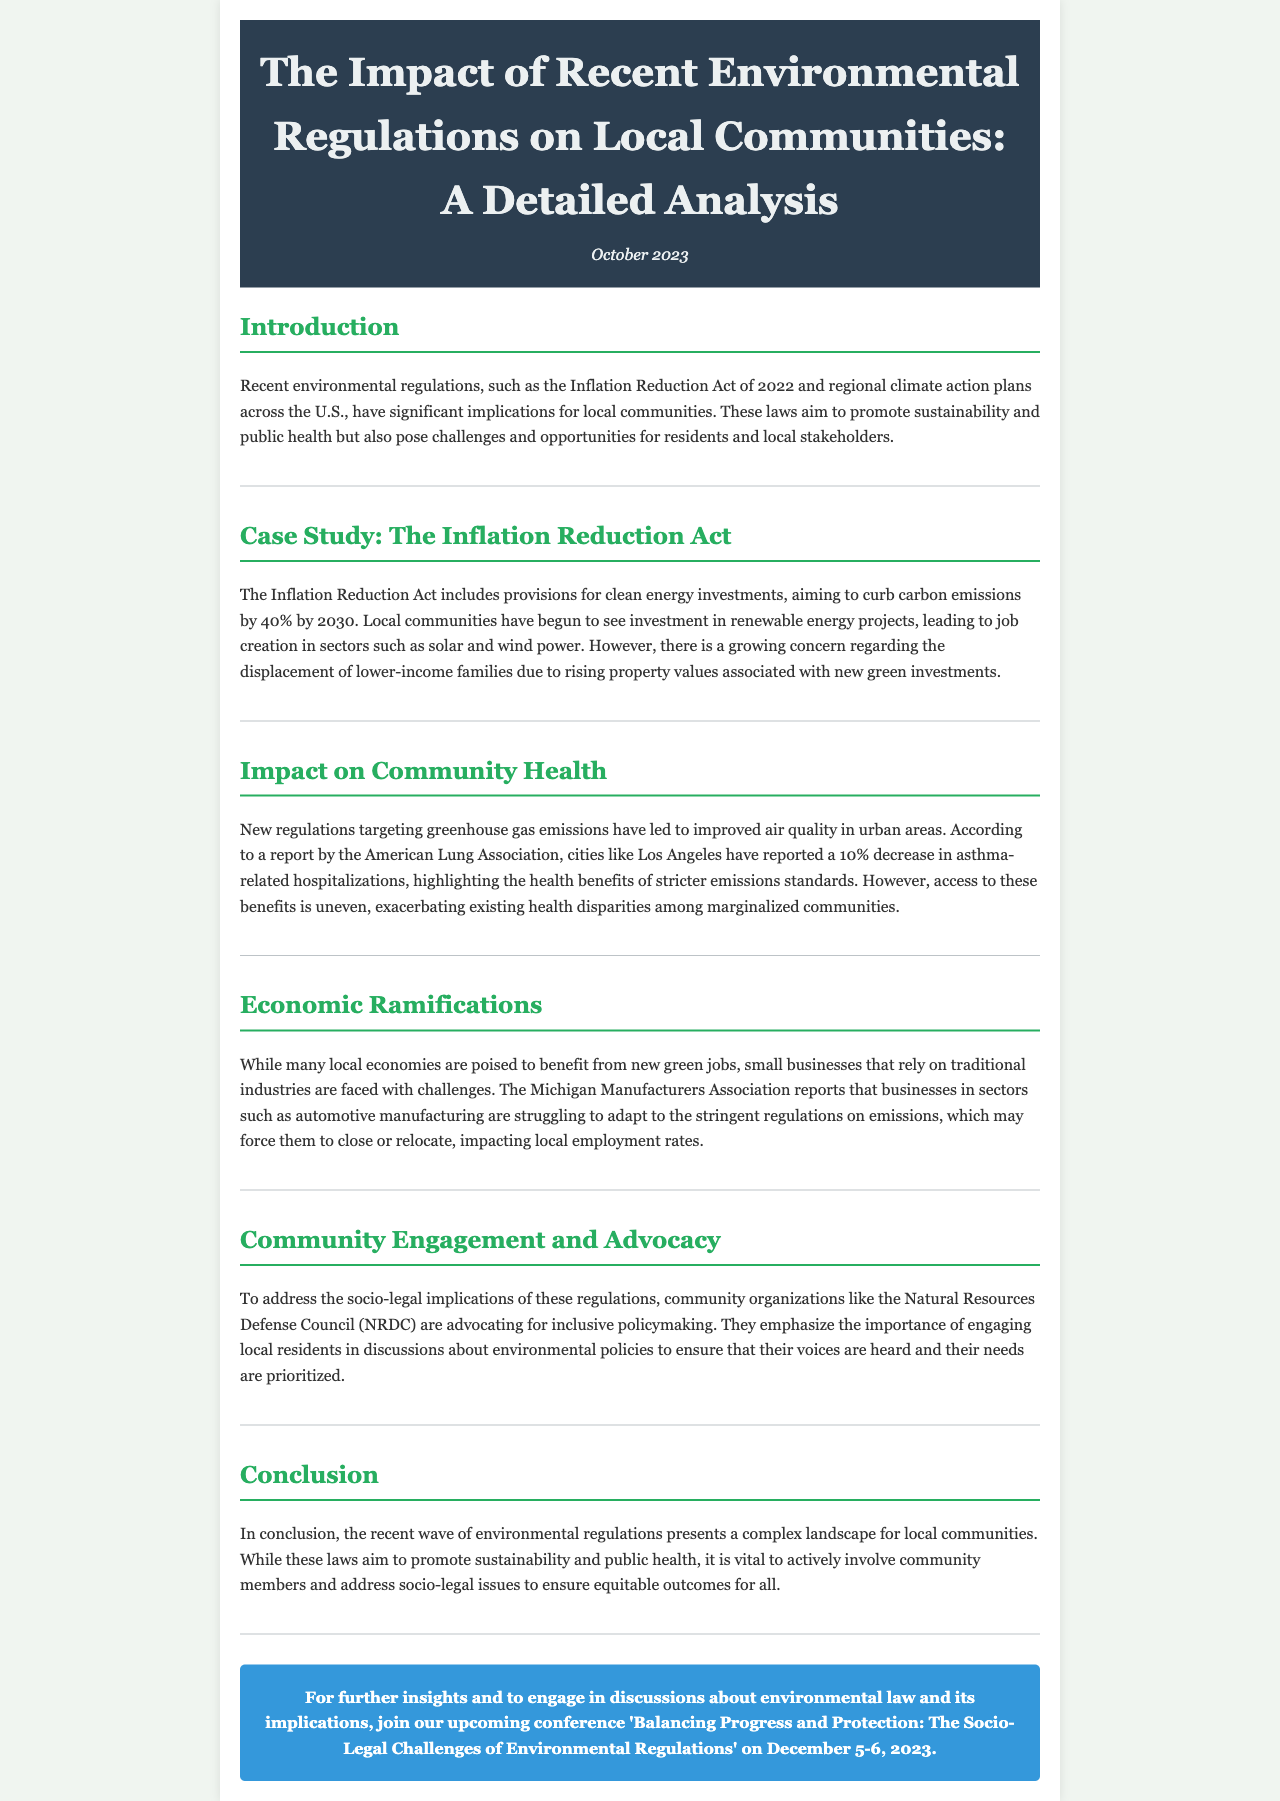what is the title of the newsletter? The title of the newsletter is the main heading found in the header section of the document.
Answer: The Impact of Recent Environmental Regulations on Local Communities: A Detailed Analysis when was the newsletter published? The publication date is noted directly under the title in the header section of the newsletter.
Answer: October 2023 what is the main objective of the Inflation Reduction Act? The main objective is mentioned in the context of provisions and aims within the case study section.
Answer: Curb carbon emissions by 40% by 2030 which organization advocates for inclusive policymaking? The organization is identified in the discussion about community engagement in the newsletter.
Answer: Natural Resources Defense Council (NRDC) what has been reported in Los Angeles regarding asthma-related hospitalizations? This information is found in the section discussing the impact on community health, presenting specific data.
Answer: 10% decrease how does the Inflation Reduction Act impact local economic sectors? The document discusses the implications for traditional industries and green jobs, which requires synthesis of content.
Answer: Struggles of small businesses what is the date of the upcoming conference mentioned in the newsletter? The date of the conference is provided in the call-to-action section of the document.
Answer: December 5-6, 2023 what color is used for the section headings in the document? The color of the section headings is specified within the styling of the newsletter’s CSS.
Answer: #27ae60 how does the newsletter emphasize community engagement? This emphasis is illustrated through the discussion of community organizations advocating for involvement in policymaking.
Answer: Engaging local residents in discussions 